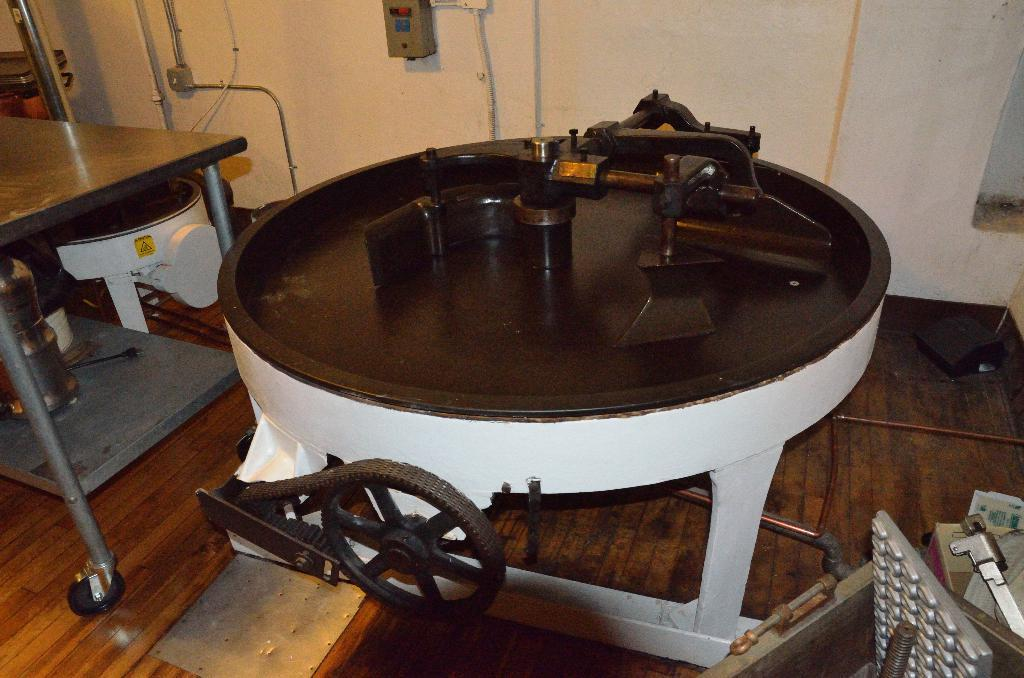What type of objects can be seen in the image that resemble a machine? There are objects in the image that resemble a machine. What can be seen connected to the machine-like objects? There are pipes visible in the image. What is visible in the background of the image? There is a wall in the background of the image. What type of curtain is hanging from the machine in the image? There is no curtain present in the image. 